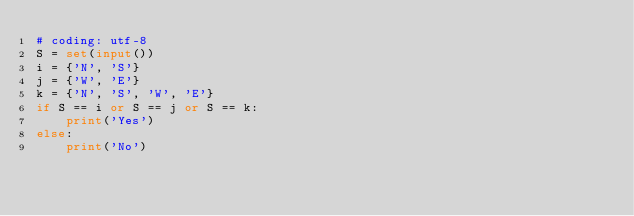<code> <loc_0><loc_0><loc_500><loc_500><_Python_># coding: utf-8
S = set(input())
i = {'N', 'S'}
j = {'W', 'E'}
k = {'N', 'S', 'W', 'E'}
if S == i or S == j or S == k:
    print('Yes')
else:
    print('No')</code> 